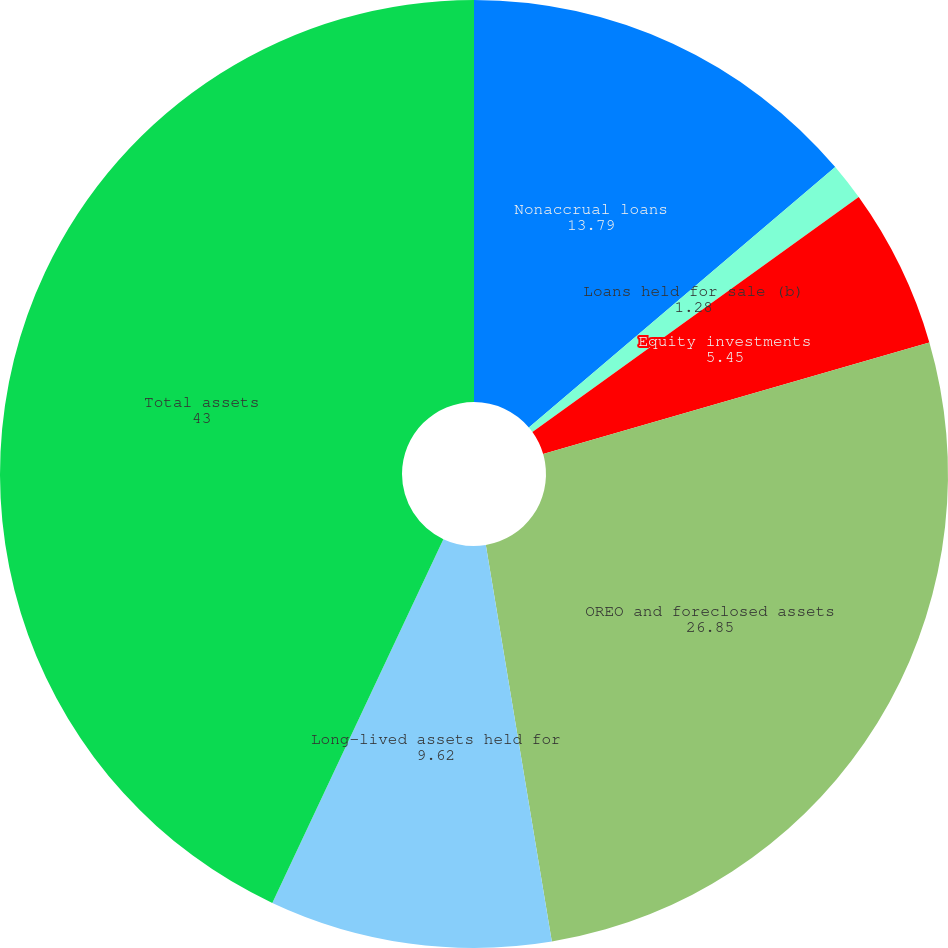Convert chart. <chart><loc_0><loc_0><loc_500><loc_500><pie_chart><fcel>Nonaccrual loans<fcel>Loans held for sale (b)<fcel>Equity investments<fcel>OREO and foreclosed assets<fcel>Long-lived assets held for<fcel>Total assets<nl><fcel>13.79%<fcel>1.28%<fcel>5.45%<fcel>26.85%<fcel>9.62%<fcel>43.0%<nl></chart> 